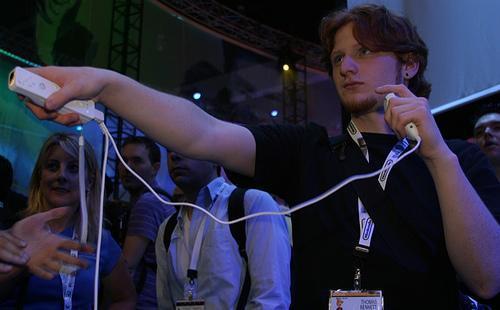How many people are in the photo?
Give a very brief answer. 5. 